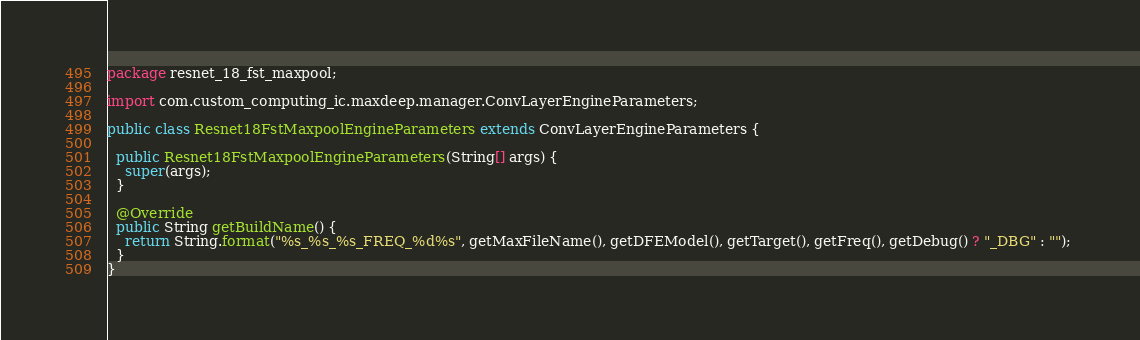<code> <loc_0><loc_0><loc_500><loc_500><_Java_>package resnet_18_fst_maxpool;

import com.custom_computing_ic.maxdeep.manager.ConvLayerEngineParameters;

public class Resnet18FstMaxpoolEngineParameters extends ConvLayerEngineParameters {

  public Resnet18FstMaxpoolEngineParameters(String[] args) {
    super(args);
  }
  
  @Override
  public String getBuildName() {
    return String.format("%s_%s_%s_FREQ_%d%s", getMaxFileName(), getDFEModel(), getTarget(), getFreq(), getDebug() ? "_DBG" : ""); 
  }
}
</code> 